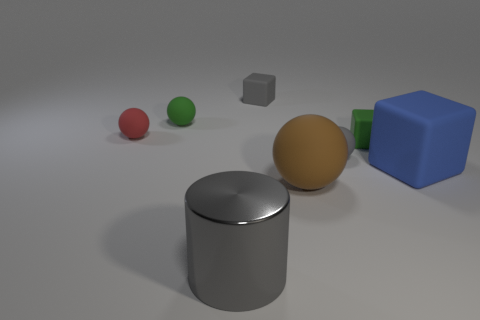Add 1 gray matte cubes. How many objects exist? 9 Subtract all tiny blocks. How many blocks are left? 1 Add 7 big gray metal cylinders. How many big gray metal cylinders are left? 8 Add 2 small rubber cylinders. How many small rubber cylinders exist? 2 Subtract all blue blocks. How many blocks are left? 2 Subtract 0 cyan blocks. How many objects are left? 8 Subtract all cubes. How many objects are left? 5 Subtract 1 balls. How many balls are left? 3 Subtract all purple cubes. Subtract all yellow balls. How many cubes are left? 3 Subtract all cyan blocks. How many blue cylinders are left? 0 